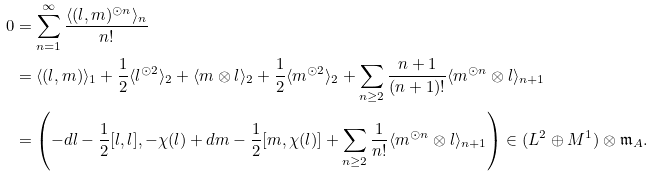<formula> <loc_0><loc_0><loc_500><loc_500>0 & = \sum _ { n = 1 } ^ { \infty } \frac { \langle ( l , m ) ^ { \odot n } \rangle _ { n } } { n ! } \\ & = \langle ( l , m ) \rangle _ { 1 } + \frac { 1 } { 2 } \langle l ^ { \odot 2 } \rangle _ { 2 } + \langle m \otimes l \rangle _ { 2 } + \frac { 1 } { 2 } \langle m ^ { \odot 2 } \rangle _ { 2 } + \sum _ { n \geq 2 } \frac { n + 1 } { ( n + 1 ) ! } \langle m ^ { \odot n } \otimes l \rangle _ { n + 1 } \\ & = \left ( - d l - \frac { 1 } { 2 } [ l , l ] , - \chi ( l ) + d m - \frac { 1 } { 2 } [ m , \chi ( l ) ] + \sum _ { n \geq 2 } \frac { 1 } { n ! } \langle m ^ { \odot n } \otimes l \rangle _ { n + 1 } \right ) \in ( L ^ { 2 } \oplus M ^ { 1 } ) \otimes \mathfrak { m } _ { A } .</formula> 